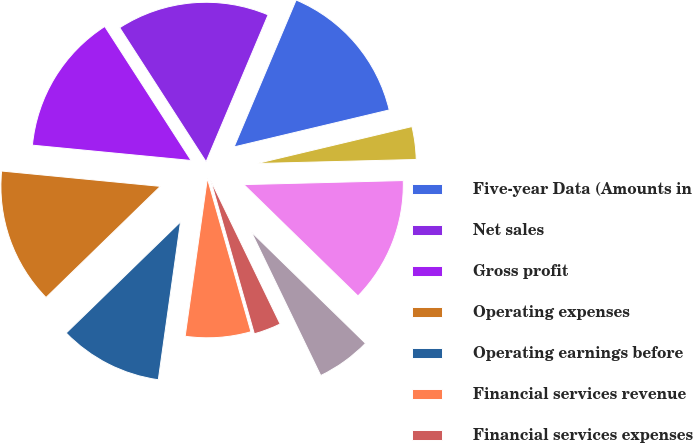Convert chart. <chart><loc_0><loc_0><loc_500><loc_500><pie_chart><fcel>Five-year Data (Amounts in<fcel>Net sales<fcel>Gross profit<fcel>Operating expenses<fcel>Operating earnings before<fcel>Financial services revenue<fcel>Financial services expenses<fcel>Operating earnings from<fcel>Operating earnings<fcel>Interest expense<nl><fcel>14.92%<fcel>15.47%<fcel>14.36%<fcel>13.81%<fcel>10.5%<fcel>6.63%<fcel>2.76%<fcel>5.53%<fcel>12.71%<fcel>3.32%<nl></chart> 